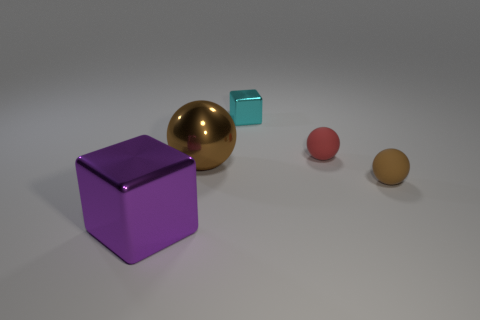Subtract all matte spheres. How many spheres are left? 1 Subtract all purple blocks. How many brown spheres are left? 2 Subtract all green spheres. Subtract all purple cylinders. How many spheres are left? 3 Add 3 small brown rubber balls. How many objects exist? 8 Add 2 brown objects. How many brown objects are left? 4 Add 2 red spheres. How many red spheres exist? 3 Subtract 0 green cylinders. How many objects are left? 5 Subtract all blocks. How many objects are left? 3 Subtract all large cyan shiny cubes. Subtract all tiny red matte spheres. How many objects are left? 4 